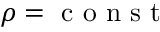<formula> <loc_0><loc_0><loc_500><loc_500>\rho = c o n s t</formula> 